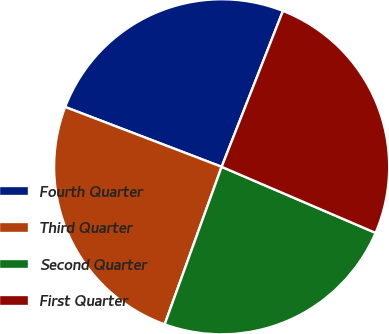Convert chart to OTSL. <chart><loc_0><loc_0><loc_500><loc_500><pie_chart><fcel>Fourth Quarter<fcel>Third Quarter<fcel>Second Quarter<fcel>First Quarter<nl><fcel>25.15%<fcel>25.29%<fcel>24.07%<fcel>25.49%<nl></chart> 